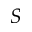Convert formula to latex. <formula><loc_0><loc_0><loc_500><loc_500>S</formula> 